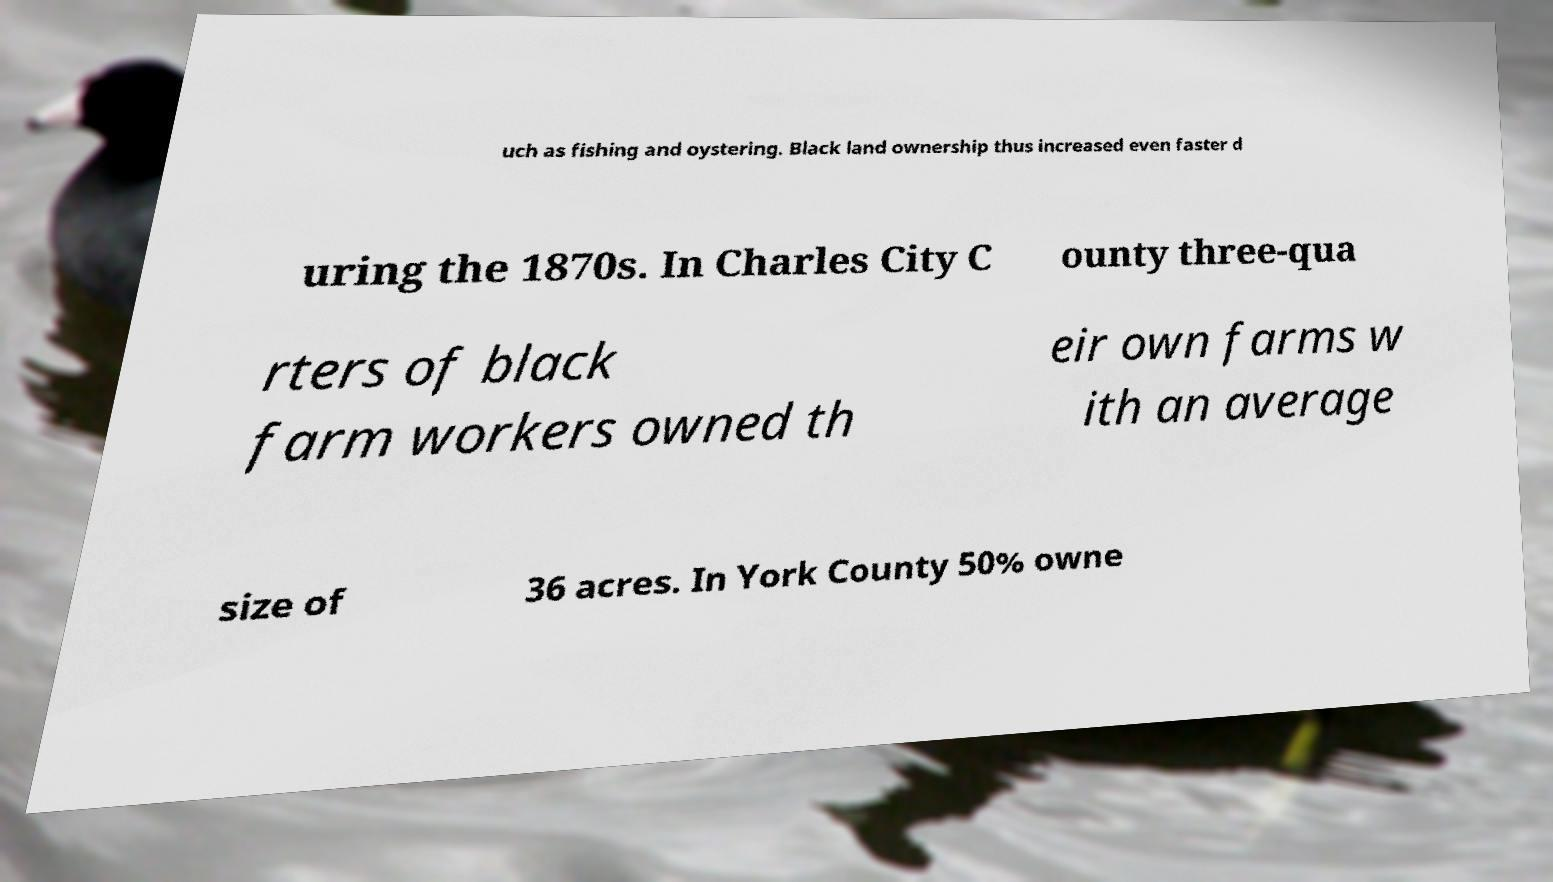There's text embedded in this image that I need extracted. Can you transcribe it verbatim? uch as fishing and oystering. Black land ownership thus increased even faster d uring the 1870s. In Charles City C ounty three-qua rters of black farm workers owned th eir own farms w ith an average size of 36 acres. In York County 50% owne 